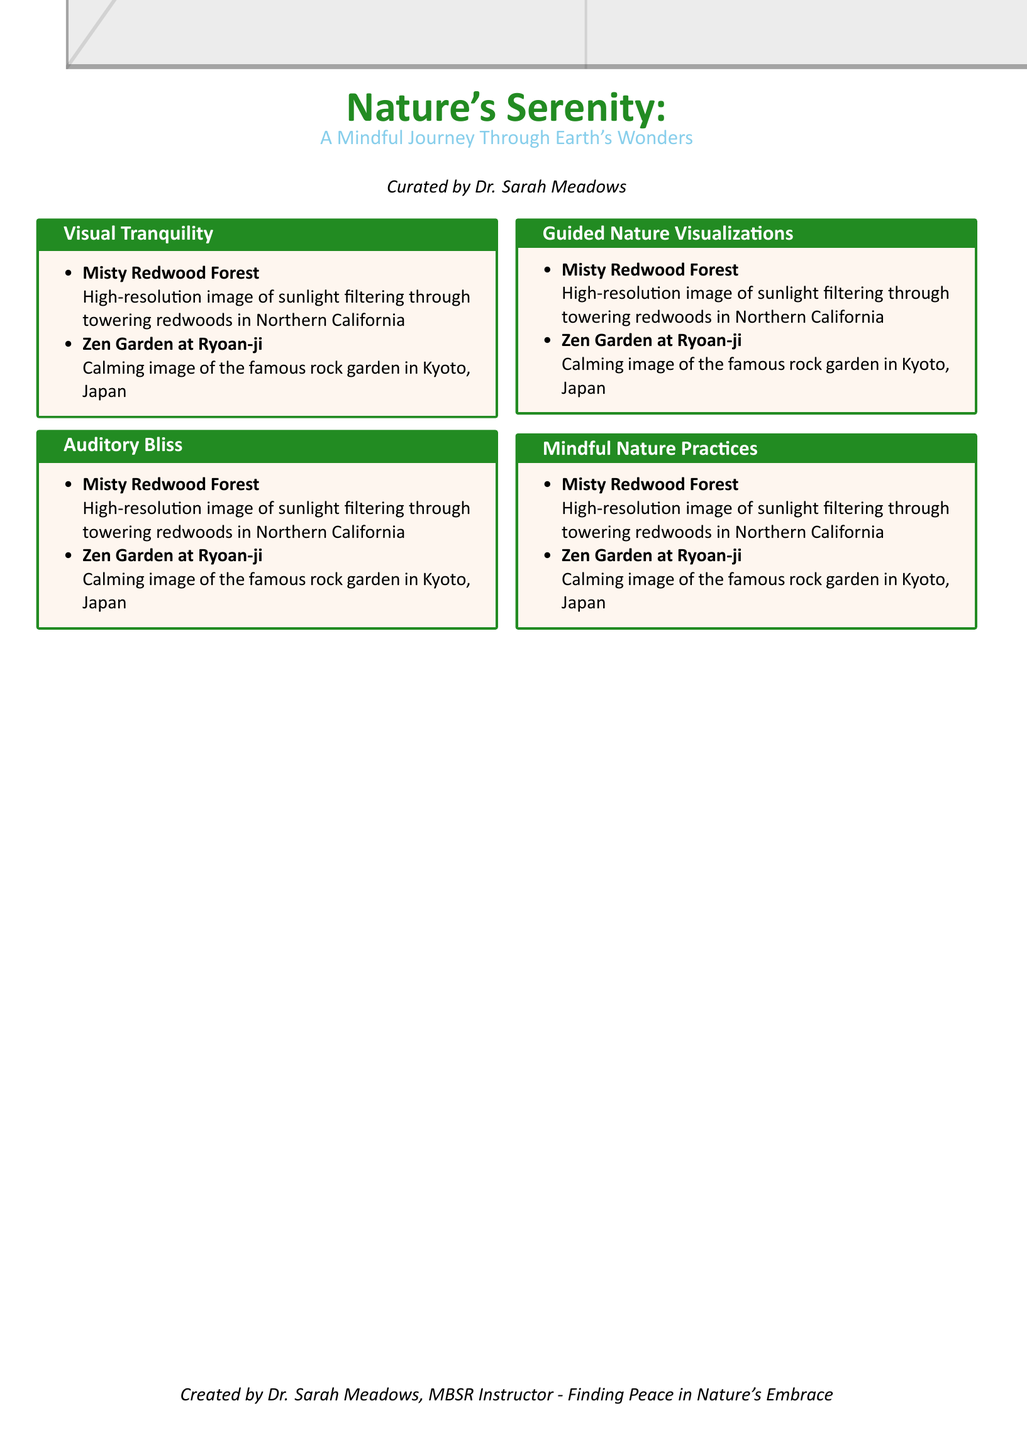What is the title of the catalog? The title appears prominently at the beginning of the document.
Answer: Nature's Serenity Who curated the collection? The document mentions the curator's name in the introduction section.
Answer: Dr. Sarah Meadows How many sections are there in the catalog? There are four distinct sections listed in the document.
Answer: 4 What type of images are displayed in the "Visual Tranquility" section? The document provides examples of images that can be found in this section.
Answer: High-resolution images Where is the Zen Garden located? The document specifies the location of the Zen Garden in its description.
Answer: Kyoto, Japan What is the theme of the entire catalog? The theme is conveyed through the title and subtitle of the document.
Answer: A Mindful Journey Through Earth's Wonders Which section features sound recordings? The catalog explicitly lists its content sections, and one contains sound recordings.
Answer: Auditory Bliss What aspect of nature does Dr. Sarah Meadows focus on in this collection? The document implies the focus through its entirety and title.
Answer: Nature's Embrace 